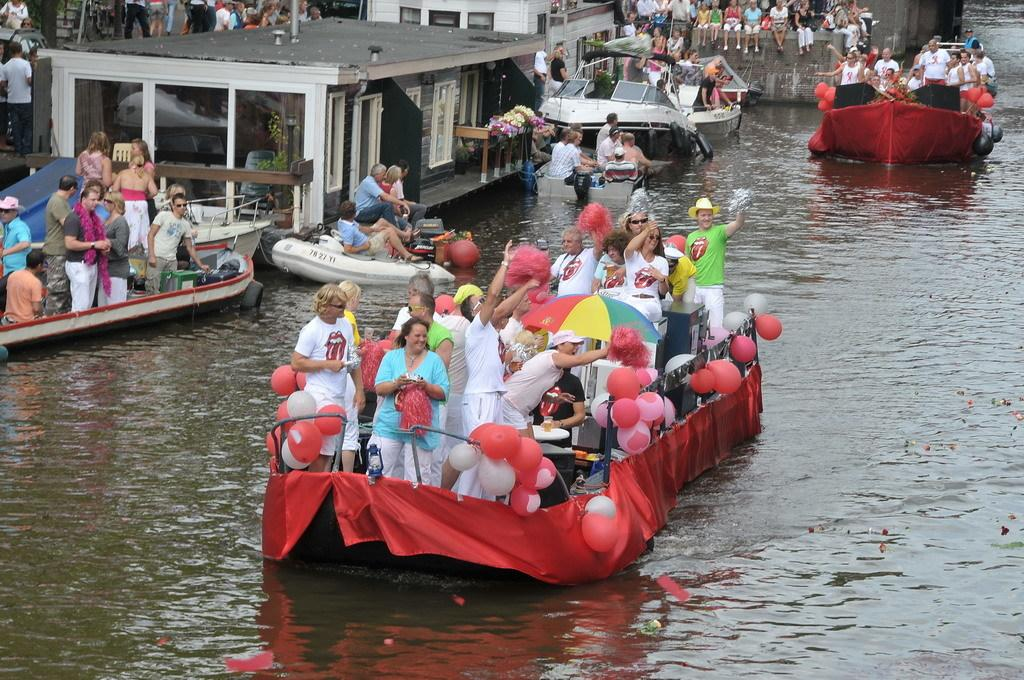Who is present in the image? There are persons in the image. What are the persons doing in the image? The persons are on boats. What is the location of the boats in the image? The boats are floating on water. What structures can be seen at the top of the image? There are shelters at the top of the image. What type of father is sitting on the shelf in the image? There is no father or shelf present in the image. 